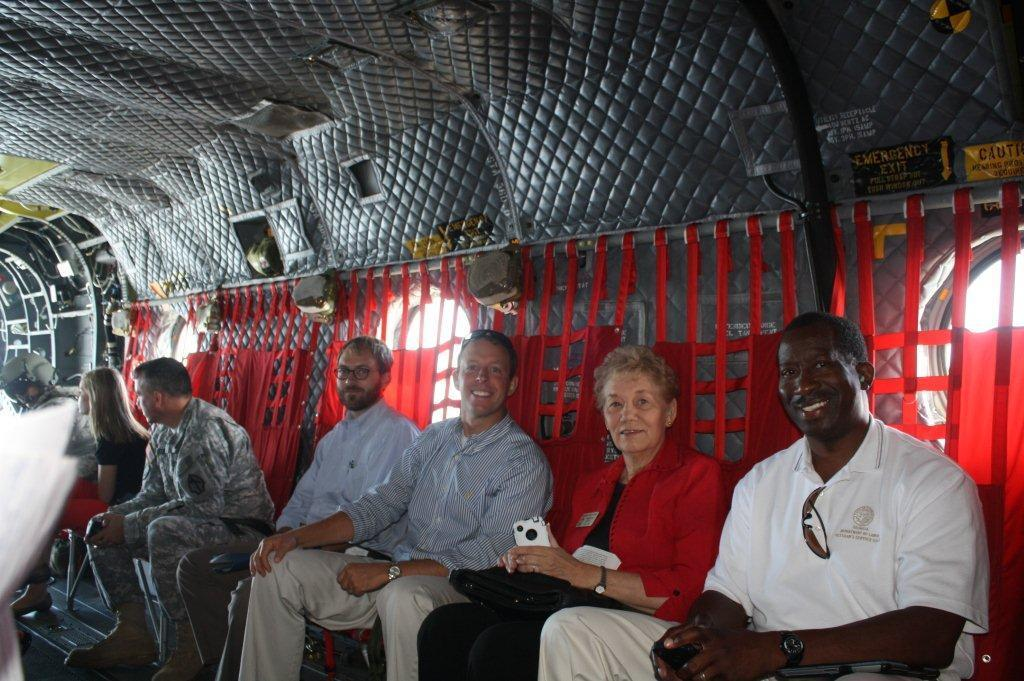What are the persons in the image doing? The persons in the image are sitting. Can you describe the attire of the persons? The persons are wearing different color dresses. What is the emotional state of some of the persons? Some of the persons are smiling. What can be seen in the background of the image? There are windows with red color curtains and a roof visible in the background. What type of meal is being served in the image? There is no meal present in the image; it only shows persons sitting and wearing different color dresses. 